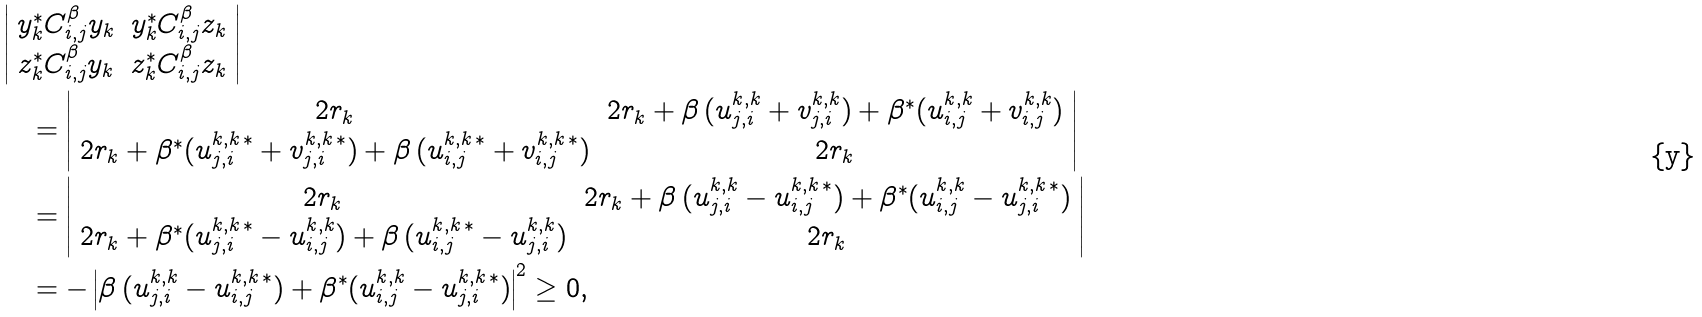Convert formula to latex. <formula><loc_0><loc_0><loc_500><loc_500>& \left | \begin{array} { c c } y _ { k } ^ { \ast } C _ { i , j } ^ { \beta } y _ { k } & y _ { k } ^ { \ast } C _ { i , j } ^ { \beta } z _ { k } \\ z _ { k } ^ { \ast } C _ { i , j } ^ { \beta } y _ { k } & z _ { k } ^ { \ast } C _ { i , j } ^ { \beta } z _ { k } \end{array} \right | \\ & \quad = \left | \begin{array} { c c } 2 r _ { k } & 2 r _ { k } + \beta \, ( u _ { j , i } ^ { k , k } + v _ { j , i } ^ { k , k } ) + \beta ^ { * } ( u _ { i , j } ^ { k , k } + v _ { i , j } ^ { k , k } ) \\ 2 r _ { k } + \beta ^ { * } ( u _ { j , i } ^ { k , k \, * } + v _ { j , i } ^ { k , k \, * } ) + \beta \, ( u _ { i , j } ^ { k , k \, * } + v _ { i , j } ^ { k , k \, * } ) & 2 r _ { k } \end{array} \right | \\ & \quad = \left | \begin{array} { c c } 2 r _ { k } & 2 r _ { k } + \beta \, ( u _ { j , i } ^ { k , k } - u _ { i , j } ^ { k , k \, * } ) + \beta ^ { * } ( u _ { i , j } ^ { k , k } - u _ { j , i } ^ { k , k \, * } ) \\ 2 r _ { k } + \beta ^ { * } ( u _ { j , i } ^ { k , k \, * } - u _ { i , j } ^ { k , k } ) + \beta \, ( u _ { i , j } ^ { k , k \, * } - u _ { j , i } ^ { k , k } ) & 2 r _ { k } \end{array} \right | \\ & \quad = - \left | \beta \, ( u _ { j , i } ^ { k , k } - u _ { i , j } ^ { k , k \, * } ) + \beta ^ { * } ( u _ { i , j } ^ { k , k } - u _ { j , i } ^ { k , k \, * } ) \right | ^ { 2 } \geq 0 ,</formula> 